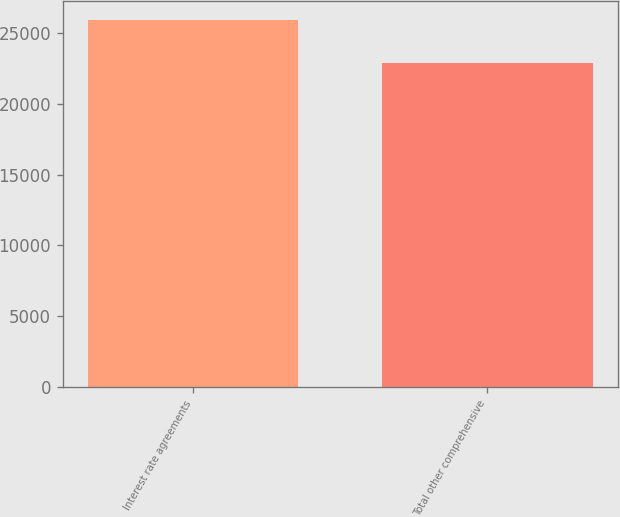<chart> <loc_0><loc_0><loc_500><loc_500><bar_chart><fcel>Interest rate agreements<fcel>Total other comprehensive<nl><fcel>25966<fcel>22944<nl></chart> 